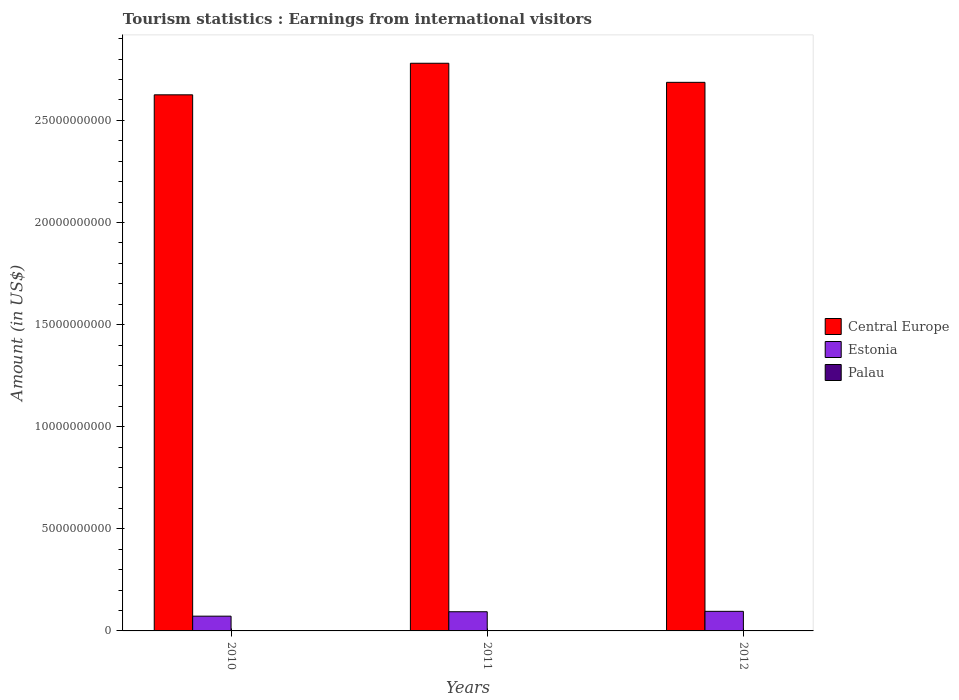How many different coloured bars are there?
Provide a short and direct response. 3. How many groups of bars are there?
Offer a very short reply. 3. How many bars are there on the 3rd tick from the left?
Make the answer very short. 3. What is the label of the 2nd group of bars from the left?
Your answer should be very brief. 2011. What is the earnings from international visitors in Palau in 2011?
Your answer should be compact. 1.66e+07. Across all years, what is the maximum earnings from international visitors in Central Europe?
Provide a short and direct response. 2.78e+1. Across all years, what is the minimum earnings from international visitors in Estonia?
Keep it short and to the point. 7.23e+08. In which year was the earnings from international visitors in Palau minimum?
Your answer should be very brief. 2010. What is the total earnings from international visitors in Central Europe in the graph?
Make the answer very short. 8.09e+1. What is the difference between the earnings from international visitors in Central Europe in 2011 and that in 2012?
Ensure brevity in your answer.  9.34e+08. What is the difference between the earnings from international visitors in Palau in 2010 and the earnings from international visitors in Estonia in 2012?
Give a very brief answer. -9.44e+08. What is the average earnings from international visitors in Estonia per year?
Your response must be concise. 8.74e+08. In the year 2010, what is the difference between the earnings from international visitors in Central Europe and earnings from international visitors in Estonia?
Keep it short and to the point. 2.55e+1. In how many years, is the earnings from international visitors in Central Europe greater than 23000000000 US$?
Provide a succinct answer. 3. What is the ratio of the earnings from international visitors in Central Europe in 2010 to that in 2011?
Your response must be concise. 0.94. Is the earnings from international visitors in Palau in 2010 less than that in 2012?
Your response must be concise. Yes. Is the difference between the earnings from international visitors in Central Europe in 2010 and 2011 greater than the difference between the earnings from international visitors in Estonia in 2010 and 2011?
Keep it short and to the point. No. What is the difference between the highest and the lowest earnings from international visitors in Estonia?
Your response must be concise. 2.36e+08. Is the sum of the earnings from international visitors in Central Europe in 2011 and 2012 greater than the maximum earnings from international visitors in Palau across all years?
Your response must be concise. Yes. What does the 1st bar from the left in 2012 represents?
Keep it short and to the point. Central Europe. What does the 3rd bar from the right in 2011 represents?
Your answer should be very brief. Central Europe. Is it the case that in every year, the sum of the earnings from international visitors in Estonia and earnings from international visitors in Palau is greater than the earnings from international visitors in Central Europe?
Ensure brevity in your answer.  No. How many bars are there?
Ensure brevity in your answer.  9. How many years are there in the graph?
Your response must be concise. 3. Does the graph contain grids?
Your answer should be very brief. No. Where does the legend appear in the graph?
Your answer should be compact. Center right. How many legend labels are there?
Give a very brief answer. 3. How are the legend labels stacked?
Your answer should be very brief. Vertical. What is the title of the graph?
Your response must be concise. Tourism statistics : Earnings from international visitors. Does "Slovak Republic" appear as one of the legend labels in the graph?
Offer a very short reply. No. What is the label or title of the X-axis?
Ensure brevity in your answer.  Years. What is the label or title of the Y-axis?
Provide a short and direct response. Amount (in US$). What is the Amount (in US$) in Central Europe in 2010?
Ensure brevity in your answer.  2.63e+1. What is the Amount (in US$) in Estonia in 2010?
Ensure brevity in your answer.  7.23e+08. What is the Amount (in US$) in Palau in 2010?
Keep it short and to the point. 1.48e+07. What is the Amount (in US$) of Central Europe in 2011?
Your response must be concise. 2.78e+1. What is the Amount (in US$) in Estonia in 2011?
Keep it short and to the point. 9.39e+08. What is the Amount (in US$) in Palau in 2011?
Your answer should be compact. 1.66e+07. What is the Amount (in US$) in Central Europe in 2012?
Your answer should be very brief. 2.69e+1. What is the Amount (in US$) in Estonia in 2012?
Ensure brevity in your answer.  9.59e+08. What is the Amount (in US$) of Palau in 2012?
Give a very brief answer. 1.91e+07. Across all years, what is the maximum Amount (in US$) in Central Europe?
Your response must be concise. 2.78e+1. Across all years, what is the maximum Amount (in US$) in Estonia?
Provide a succinct answer. 9.59e+08. Across all years, what is the maximum Amount (in US$) in Palau?
Provide a succinct answer. 1.91e+07. Across all years, what is the minimum Amount (in US$) in Central Europe?
Your answer should be very brief. 2.63e+1. Across all years, what is the minimum Amount (in US$) of Estonia?
Give a very brief answer. 7.23e+08. Across all years, what is the minimum Amount (in US$) in Palau?
Offer a very short reply. 1.48e+07. What is the total Amount (in US$) of Central Europe in the graph?
Your answer should be very brief. 8.09e+1. What is the total Amount (in US$) of Estonia in the graph?
Give a very brief answer. 2.62e+09. What is the total Amount (in US$) of Palau in the graph?
Make the answer very short. 5.05e+07. What is the difference between the Amount (in US$) of Central Europe in 2010 and that in 2011?
Ensure brevity in your answer.  -1.55e+09. What is the difference between the Amount (in US$) in Estonia in 2010 and that in 2011?
Offer a terse response. -2.16e+08. What is the difference between the Amount (in US$) of Palau in 2010 and that in 2011?
Provide a succinct answer. -1.80e+06. What is the difference between the Amount (in US$) in Central Europe in 2010 and that in 2012?
Provide a succinct answer. -6.12e+08. What is the difference between the Amount (in US$) of Estonia in 2010 and that in 2012?
Give a very brief answer. -2.36e+08. What is the difference between the Amount (in US$) of Palau in 2010 and that in 2012?
Your response must be concise. -4.30e+06. What is the difference between the Amount (in US$) in Central Europe in 2011 and that in 2012?
Offer a very short reply. 9.34e+08. What is the difference between the Amount (in US$) in Estonia in 2011 and that in 2012?
Ensure brevity in your answer.  -2.00e+07. What is the difference between the Amount (in US$) of Palau in 2011 and that in 2012?
Give a very brief answer. -2.50e+06. What is the difference between the Amount (in US$) of Central Europe in 2010 and the Amount (in US$) of Estonia in 2011?
Offer a terse response. 2.53e+1. What is the difference between the Amount (in US$) of Central Europe in 2010 and the Amount (in US$) of Palau in 2011?
Your response must be concise. 2.62e+1. What is the difference between the Amount (in US$) of Estonia in 2010 and the Amount (in US$) of Palau in 2011?
Give a very brief answer. 7.06e+08. What is the difference between the Amount (in US$) of Central Europe in 2010 and the Amount (in US$) of Estonia in 2012?
Make the answer very short. 2.53e+1. What is the difference between the Amount (in US$) of Central Europe in 2010 and the Amount (in US$) of Palau in 2012?
Your answer should be compact. 2.62e+1. What is the difference between the Amount (in US$) in Estonia in 2010 and the Amount (in US$) in Palau in 2012?
Ensure brevity in your answer.  7.04e+08. What is the difference between the Amount (in US$) in Central Europe in 2011 and the Amount (in US$) in Estonia in 2012?
Give a very brief answer. 2.68e+1. What is the difference between the Amount (in US$) of Central Europe in 2011 and the Amount (in US$) of Palau in 2012?
Ensure brevity in your answer.  2.78e+1. What is the difference between the Amount (in US$) in Estonia in 2011 and the Amount (in US$) in Palau in 2012?
Provide a short and direct response. 9.20e+08. What is the average Amount (in US$) in Central Europe per year?
Provide a succinct answer. 2.70e+1. What is the average Amount (in US$) in Estonia per year?
Provide a succinct answer. 8.74e+08. What is the average Amount (in US$) in Palau per year?
Provide a succinct answer. 1.68e+07. In the year 2010, what is the difference between the Amount (in US$) in Central Europe and Amount (in US$) in Estonia?
Provide a succinct answer. 2.55e+1. In the year 2010, what is the difference between the Amount (in US$) in Central Europe and Amount (in US$) in Palau?
Your answer should be compact. 2.62e+1. In the year 2010, what is the difference between the Amount (in US$) of Estonia and Amount (in US$) of Palau?
Offer a terse response. 7.08e+08. In the year 2011, what is the difference between the Amount (in US$) in Central Europe and Amount (in US$) in Estonia?
Offer a very short reply. 2.69e+1. In the year 2011, what is the difference between the Amount (in US$) of Central Europe and Amount (in US$) of Palau?
Ensure brevity in your answer.  2.78e+1. In the year 2011, what is the difference between the Amount (in US$) in Estonia and Amount (in US$) in Palau?
Your response must be concise. 9.22e+08. In the year 2012, what is the difference between the Amount (in US$) of Central Europe and Amount (in US$) of Estonia?
Give a very brief answer. 2.59e+1. In the year 2012, what is the difference between the Amount (in US$) of Central Europe and Amount (in US$) of Palau?
Offer a very short reply. 2.68e+1. In the year 2012, what is the difference between the Amount (in US$) in Estonia and Amount (in US$) in Palau?
Provide a succinct answer. 9.40e+08. What is the ratio of the Amount (in US$) in Estonia in 2010 to that in 2011?
Give a very brief answer. 0.77. What is the ratio of the Amount (in US$) of Palau in 2010 to that in 2011?
Offer a very short reply. 0.89. What is the ratio of the Amount (in US$) of Central Europe in 2010 to that in 2012?
Your answer should be compact. 0.98. What is the ratio of the Amount (in US$) of Estonia in 2010 to that in 2012?
Keep it short and to the point. 0.75. What is the ratio of the Amount (in US$) in Palau in 2010 to that in 2012?
Your answer should be compact. 0.77. What is the ratio of the Amount (in US$) of Central Europe in 2011 to that in 2012?
Your answer should be very brief. 1.03. What is the ratio of the Amount (in US$) of Estonia in 2011 to that in 2012?
Keep it short and to the point. 0.98. What is the ratio of the Amount (in US$) in Palau in 2011 to that in 2012?
Your answer should be very brief. 0.87. What is the difference between the highest and the second highest Amount (in US$) in Central Europe?
Your answer should be very brief. 9.34e+08. What is the difference between the highest and the second highest Amount (in US$) of Estonia?
Provide a succinct answer. 2.00e+07. What is the difference between the highest and the second highest Amount (in US$) of Palau?
Your answer should be very brief. 2.50e+06. What is the difference between the highest and the lowest Amount (in US$) in Central Europe?
Give a very brief answer. 1.55e+09. What is the difference between the highest and the lowest Amount (in US$) in Estonia?
Your answer should be compact. 2.36e+08. What is the difference between the highest and the lowest Amount (in US$) of Palau?
Your response must be concise. 4.30e+06. 